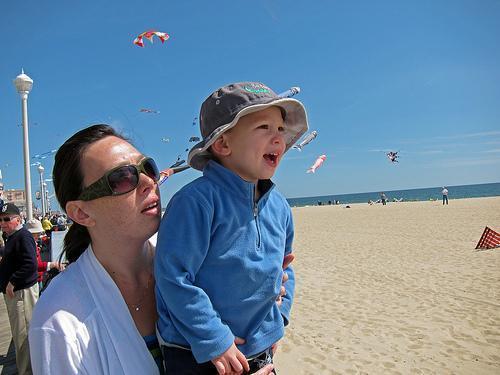How many children is the woman holding?
Give a very brief answer. 1. 